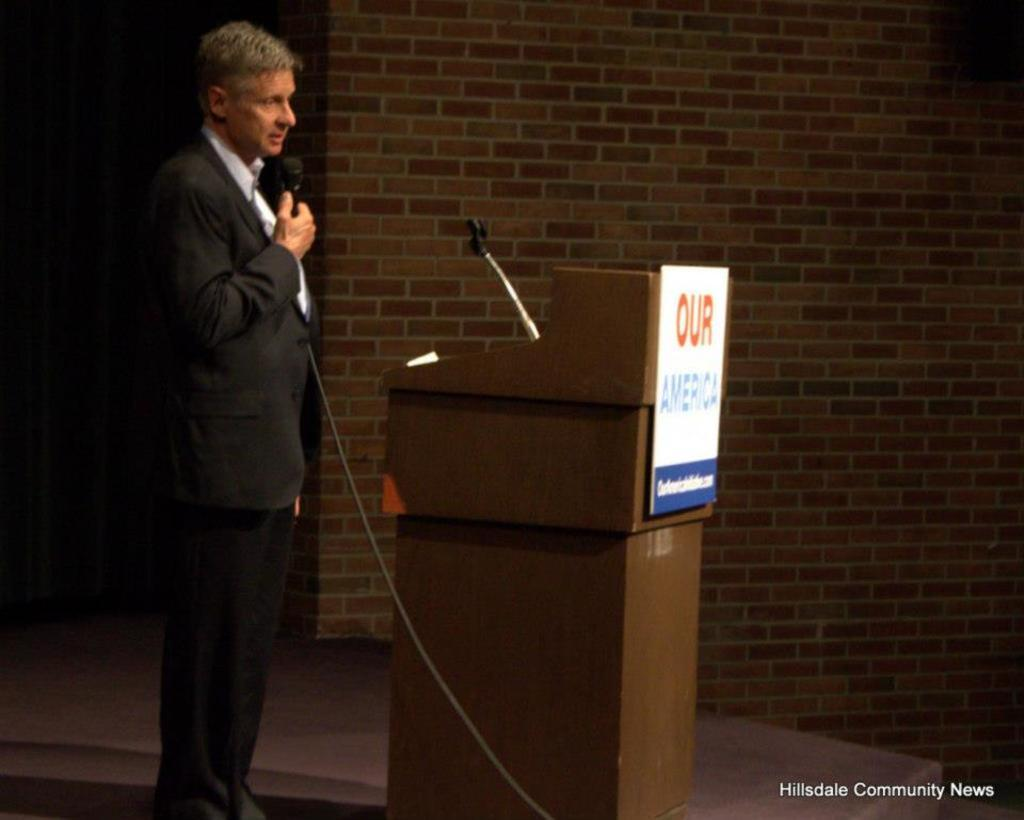<image>
Offer a succinct explanation of the picture presented. A man stands at a lectern with a sign on it saying Our America. 